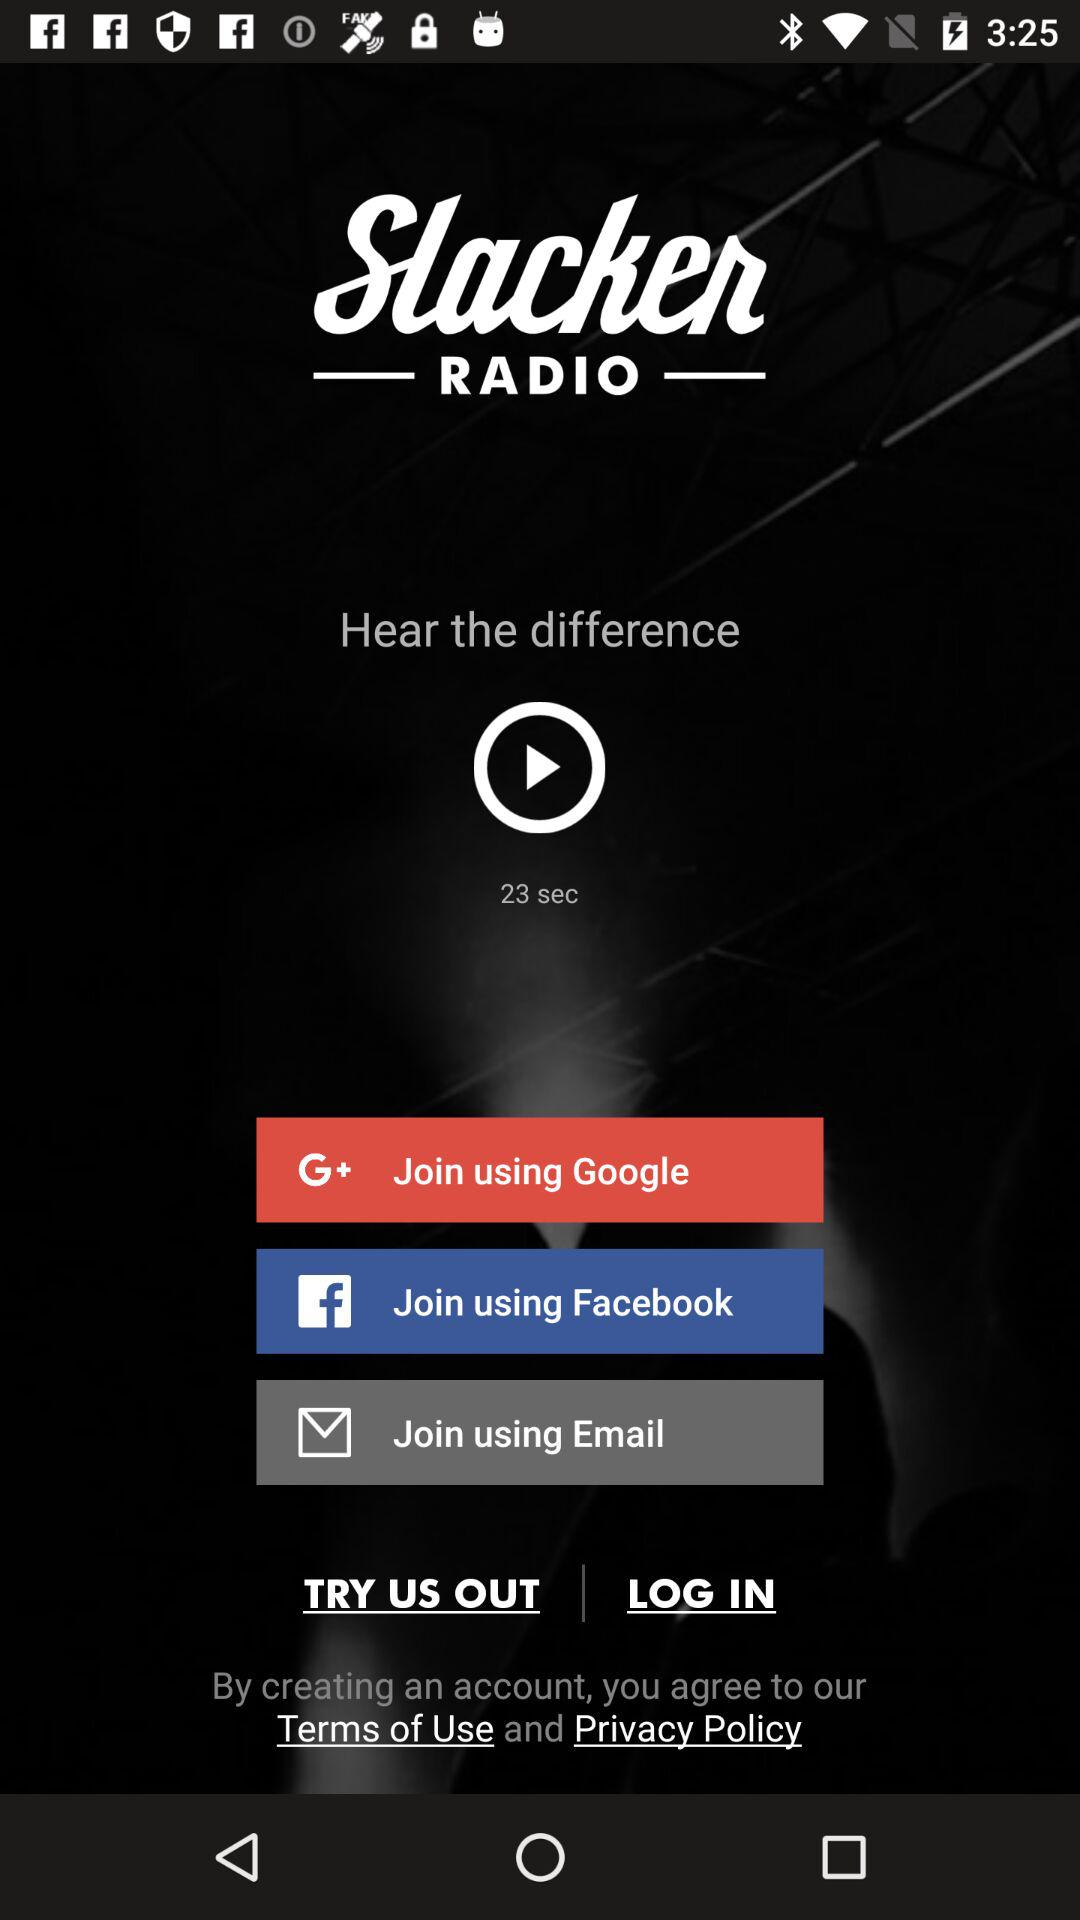Through which accounts can the user join the application? The user can join the application through "Google", "Facebook" and "Email". 